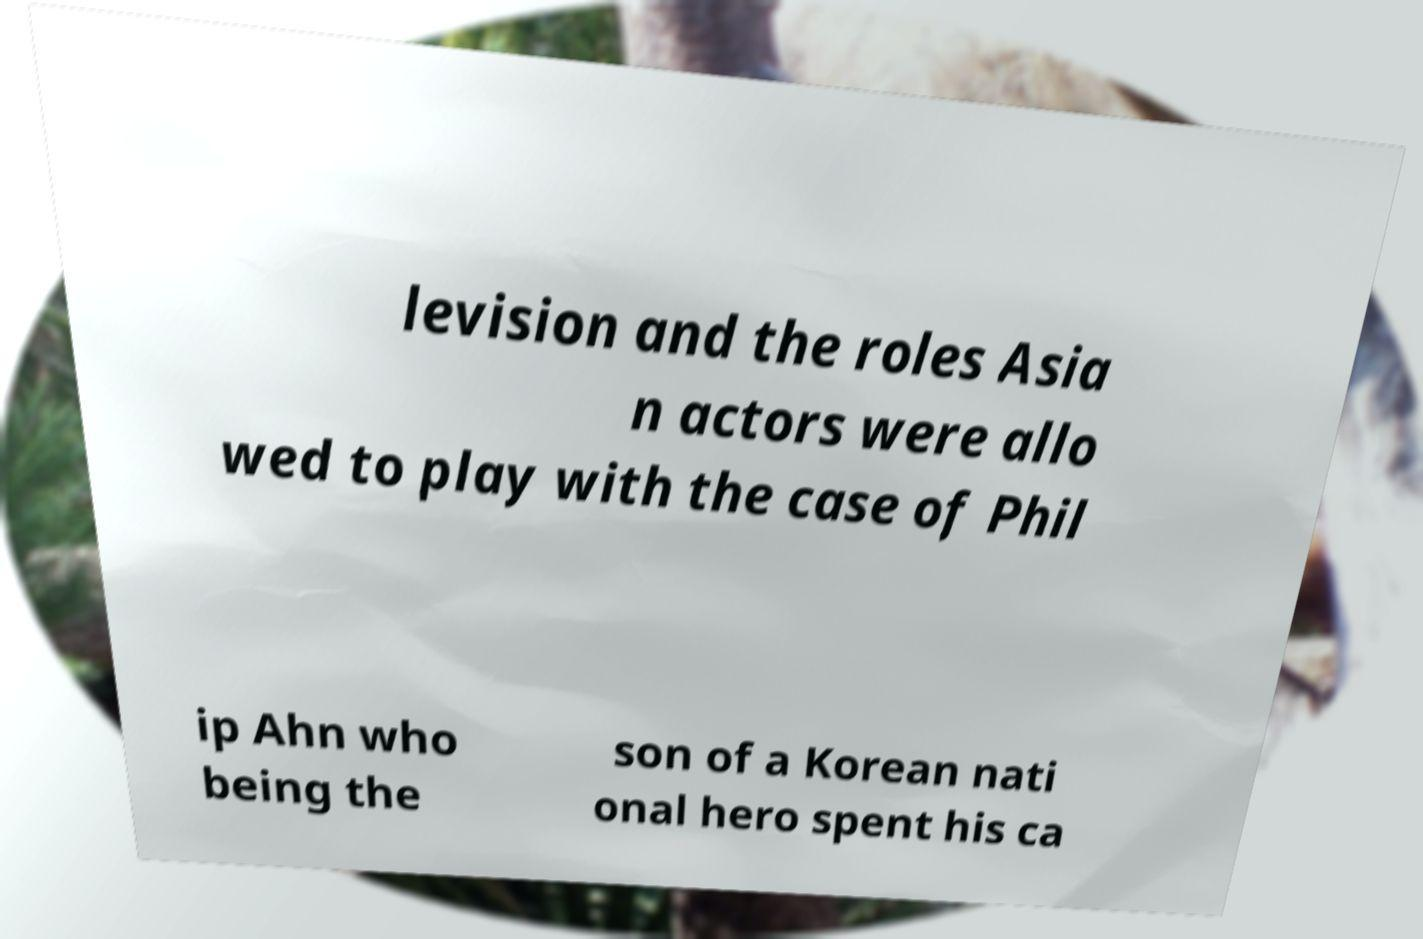Please identify and transcribe the text found in this image. levision and the roles Asia n actors were allo wed to play with the case of Phil ip Ahn who being the son of a Korean nati onal hero spent his ca 